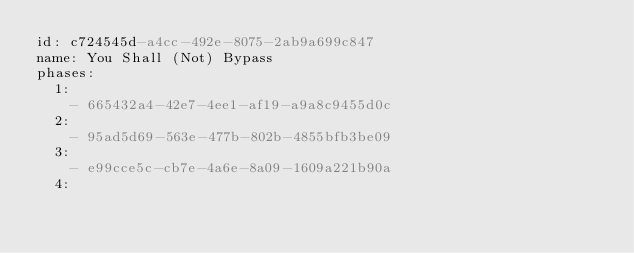<code> <loc_0><loc_0><loc_500><loc_500><_YAML_>id: c724545d-a4cc-492e-8075-2ab9a699c847
name: You Shall (Not) Bypass
phases:
  1:
    - 665432a4-42e7-4ee1-af19-a9a8c9455d0c
  2:
    - 95ad5d69-563e-477b-802b-4855bfb3be09
  3:
    - e99cce5c-cb7e-4a6e-8a09-1609a221b90a
  4:</code> 